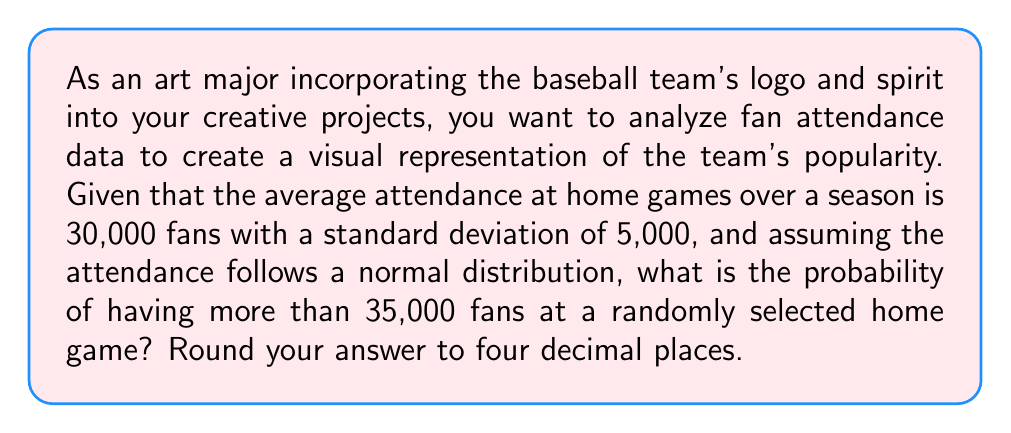Help me with this question. To solve this problem, we'll use the properties of the normal distribution and the concept of z-scores.

Step 1: Identify the given information
- Mean attendance (μ) = 30,000 fans
- Standard deviation (σ) = 5,000 fans
- We want to find P(X > 35,000), where X is the attendance at a randomly selected home game

Step 2: Calculate the z-score for 35,000 fans
The z-score formula is: $z = \frac{x - μ}{σ}$

$z = \frac{35,000 - 30,000}{5,000} = \frac{5,000}{5,000} = 1$

Step 3: Use the standard normal distribution table or calculator
We need to find P(Z > 1), where Z is the standard normal random variable.

Using a standard normal table or calculator, we find:
P(Z > 1) = 1 - P(Z ≤ 1) = 1 - 0.8413 = 0.1587

Step 4: Round the result to four decimal places
0.1587 rounded to four decimal places is 0.1587.

Therefore, the probability of having more than 35,000 fans at a randomly selected home game is 0.1587 or 15.87%.
Answer: 0.1587 